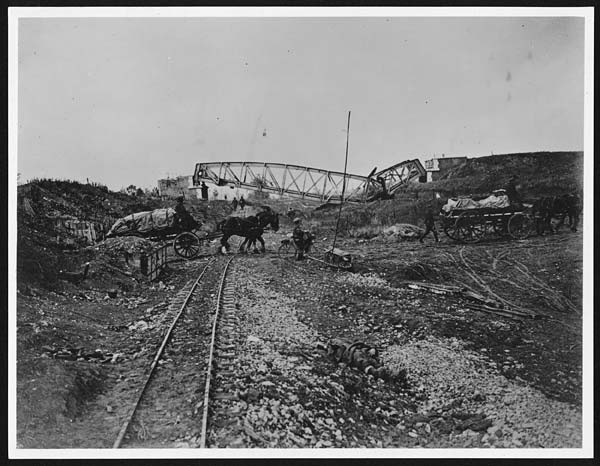Create a story about the people in the image, focusing on a specific individual. In the midst of the bustling scene, a young man named Jacob stands out. Jacob, barely 18, had traveled from a small village to work on the railroad to support his family. He wakes up every day before dawn, braving the chill of the early morning. Dressed in worn-out clothes, he joins his fellow workers, lifting heavy rails and hammering spikes with steely determination. Despite the exhaustion, Jacob finds moments of solace under the starlit sky, dreaming of the day the railroad will be completed and he can return home to his family with pride and a pocketful of savings. His story is a testament to the resilience and dreams of the countless nameless laborers who paved the way for progress. If you could ask any question to one of the workers in the image, what would it be and why? I would ask, 'What motivates you to keep working despite the obvious hardships and challenges?' This question would provide insight into the personal sacrifices and aspirations that drive individuals to endure such grueling work, shedding light on the human spirit and determination during a transformative era in history.  Imagine a conversation between a worker and his family back home. Write a letter from the worker to his family describing his life and work. Dear Family,

I hope this letter finds you in good health and high spirits. Life here on the railroad is tough but rewarding. Our days are long, starting before the sun rises and often not ending until it is well into the night. The work is backbreaking, but I find strength in knowing it’s for a brighter future for all of us. I’ve made some good friends here, and we support each other through the toughest times. The landscape is beautiful, and I often find myself marveling at the sight of the mountains and valleys we are traversing. I miss you all dearly and can’t wait for the day when I can come home and share all these stories in person. Until then, keep me in your thoughts and prayers.

With love,
Jacob 